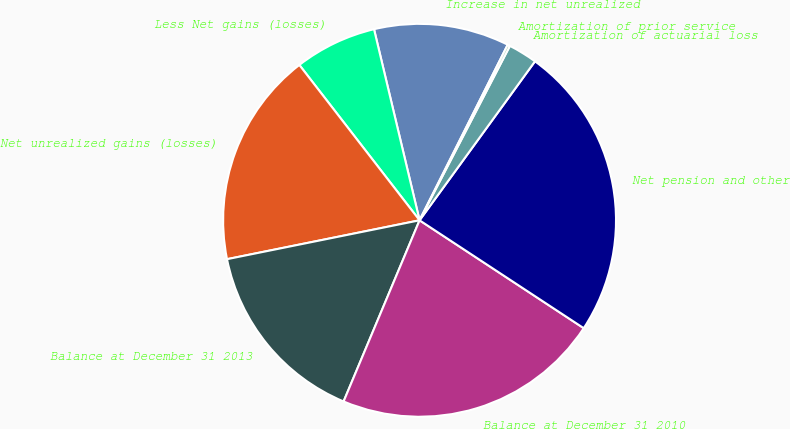Convert chart to OTSL. <chart><loc_0><loc_0><loc_500><loc_500><pie_chart><fcel>Increase in net unrealized<fcel>Less Net gains (losses)<fcel>Net unrealized gains (losses)<fcel>Balance at December 31 2013<fcel>Balance at December 31 2010<fcel>Net pension and other<fcel>Amortization of actuarial loss<fcel>Amortization of prior service<nl><fcel>11.13%<fcel>6.76%<fcel>17.69%<fcel>15.51%<fcel>22.07%<fcel>24.26%<fcel>2.39%<fcel>0.2%<nl></chart> 